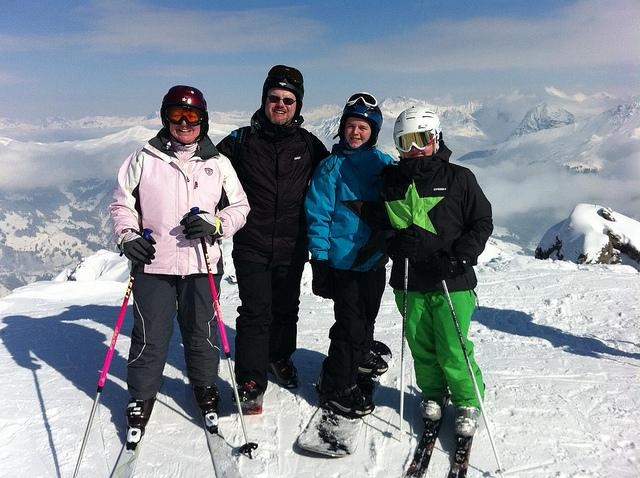What is a country that is famously a host to this sport?

Choices:
A) kenya
B) australia
C) switzerland
D) peru switzerland 